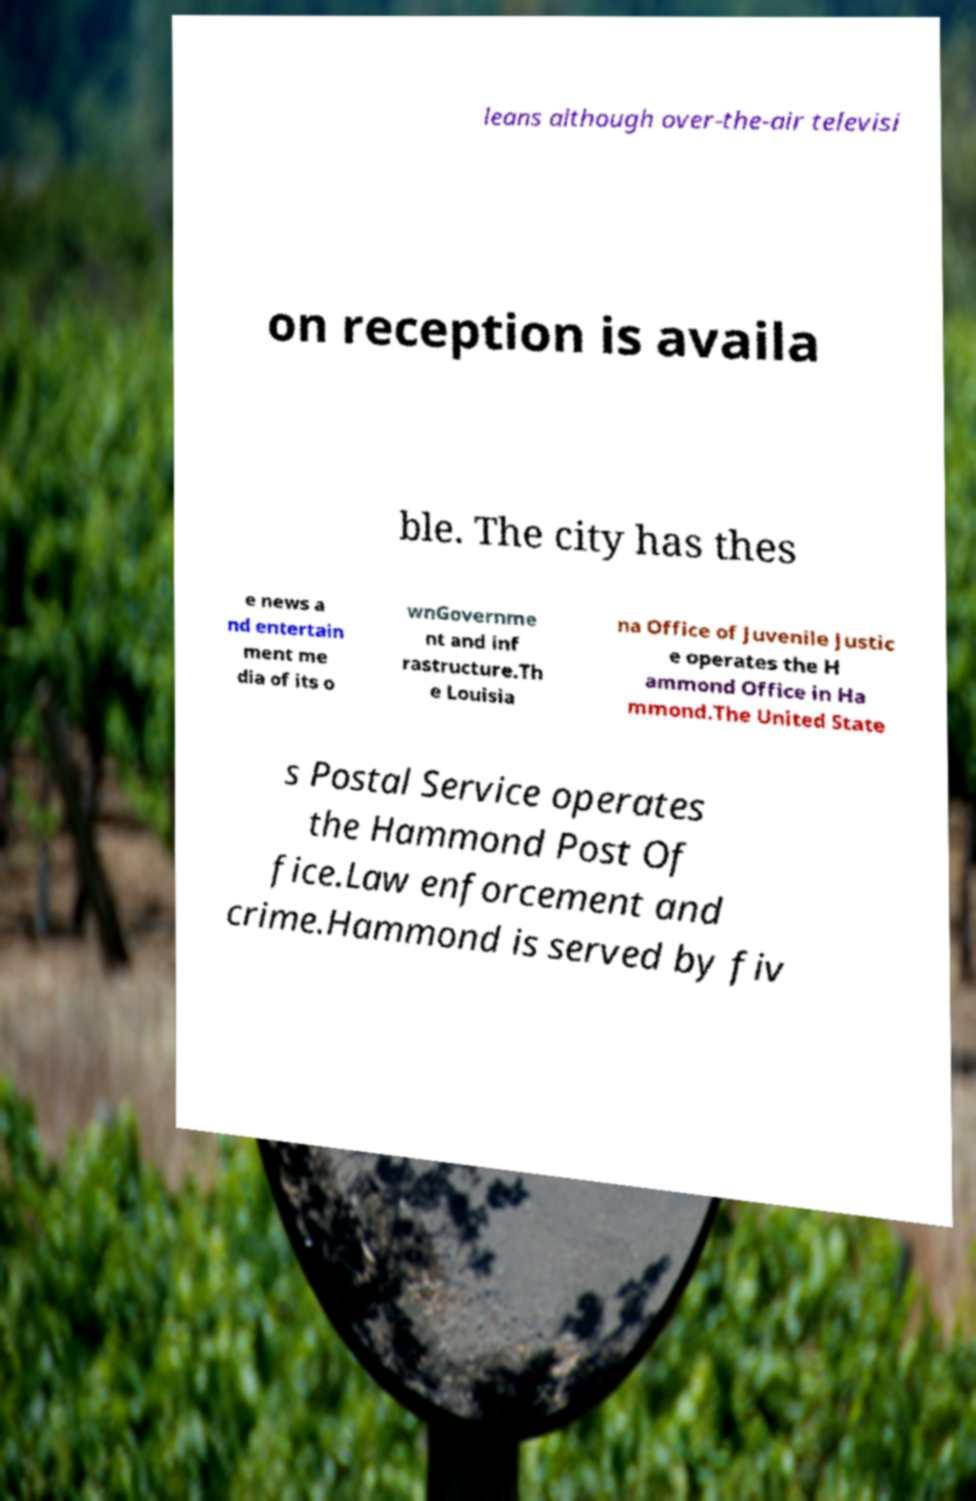Can you accurately transcribe the text from the provided image for me? leans although over-the-air televisi on reception is availa ble. The city has thes e news a nd entertain ment me dia of its o wnGovernme nt and inf rastructure.Th e Louisia na Office of Juvenile Justic e operates the H ammond Office in Ha mmond.The United State s Postal Service operates the Hammond Post Of fice.Law enforcement and crime.Hammond is served by fiv 